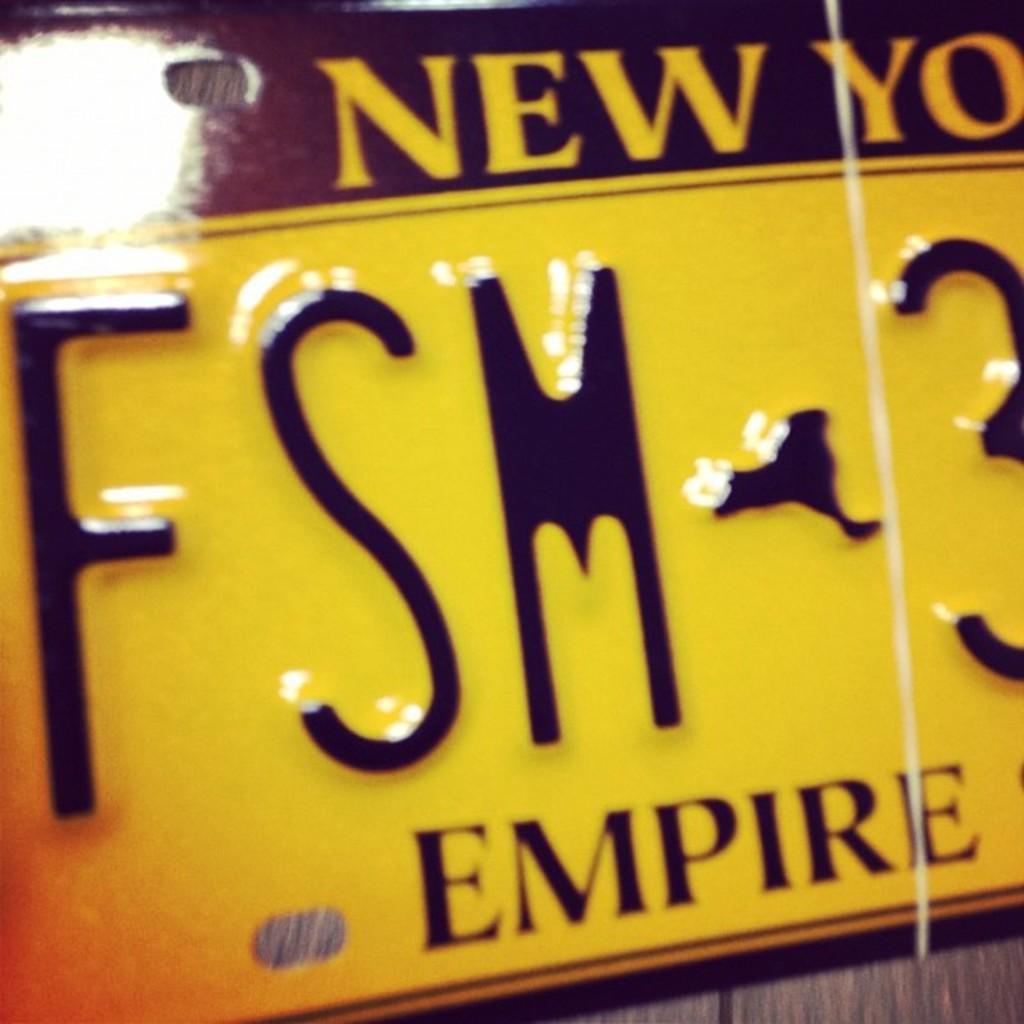How would you summarize this image in a sentence or two? In this image I can see the board which is in black and yellow color and something is written on it. It is on the brown color surface. 